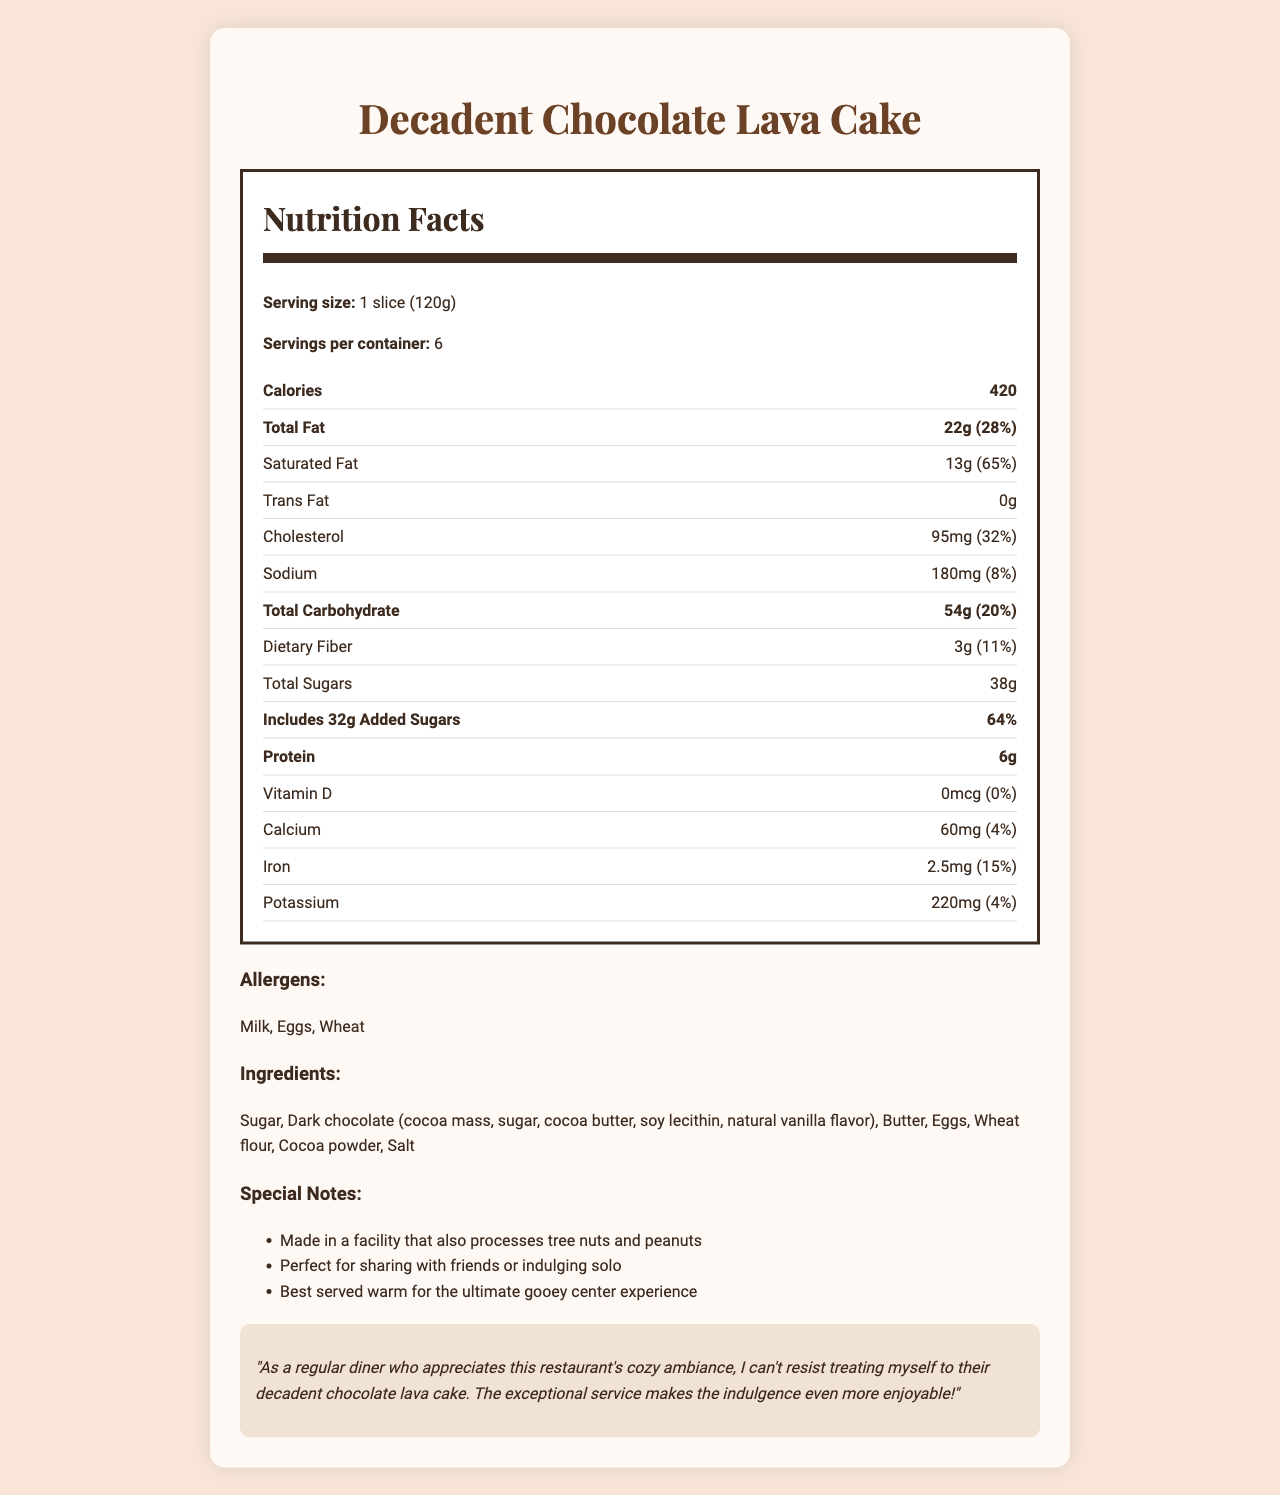what is the serving size of the cake? The serving size is clearly mentioned in the document as "1 slice (120g)".
Answer: 1 slice (120g) how many calories are in one serving? The document states that there are 420 calories in one serving.
Answer: 420 what is the total amount of sugars in a serving? The total sugars amount is listed as 38g in the nutrition label.
Answer: 38g how many servings are in one container? The document mentions that there are 6 servings per container.
Answer: 6 what allergens does this cake contain? The allergens are specified in the document's allergens section.
Answer: Milk, Eggs, Wheat what percentage of daily value for saturated fat is in one serving? The saturated fat daily value percentage is 65% as noted in the document.
Answer: 65% how much protein does one slice contain? The protein content per serving is listed as 6g.
Answer: 6g how much dietary fiber is in one serving? The dietary fiber content is given as 3g per serving.
Answer: 3g how many grams of added sugars are included in one serving? The document lists 32g of added sugars in one serving.
Answer: 32g which ingredient is not listed in the ingredients section? A. Sugar B. Butter C. Peanuts D. Cocoa powder The ingredients section does not mention peanuts, but it does mention they are processed in the facility (special notes).
Answer: C. Peanuts what is the daily value percentage of calcium in the cake? A. 0% B. 4% C. 11% D. 15% The daily value percentage of calcium is listed as 4% in the document.
Answer: B. 4% is this cake suitable for someone with a peanut allergy? The document mentions that the cake is made in a facility that processes tree nuts and peanuts, hence it's not suitable for someone with a peanut allergy.
Answer: No summarize the content of the document. The document is a comprehensive overview of the chocolate lava cake's nutrition facts, ingredients, allergens, and special notes that make it appealing to consumers.
Answer: The document provides the nutrition facts and ingredients for a decadent chocolate lava cake dessert. It details the serving size, calories, fat content, sugar levels, protein, dietary fiber, and various other nutrients, including their daily value percentages. The document also lists allergens, ingredients, and special notes, along with a customer testimonial praising the cake and the restaurant's ambiance and service. how many grams of trans fat does the cake contain per serving? The trans fat content is listed as 0g per serving.
Answer: 0g what is the total carbohydrate content in one slice? The total carbohydrate content is 54g per serving.
Answer: 54g does the cake contain any Vitamin D? The nutrition facts indicate that there is 0mcg Vitamin D in the cake.
Answer: No what is the serving suggestion to enjoy the cake at its best? The special notes section suggests serving the cake warm for the best experience.
Answer: Best served warm for the ultimate gooey center experience how much cholesterol does one slice contain? A. 32% B. 95mg C. 32mg D. 65mg The cholesterol content for one serving of the cake is 95mg.
Answer: B. 95mg is there enough information to determine if this cake is gluten-free? The document does not provide sufficient information to determine if the cake is gluten-free. It contains wheat flour, which is a source of gluten, making it not gluten-free.
Answer: No 